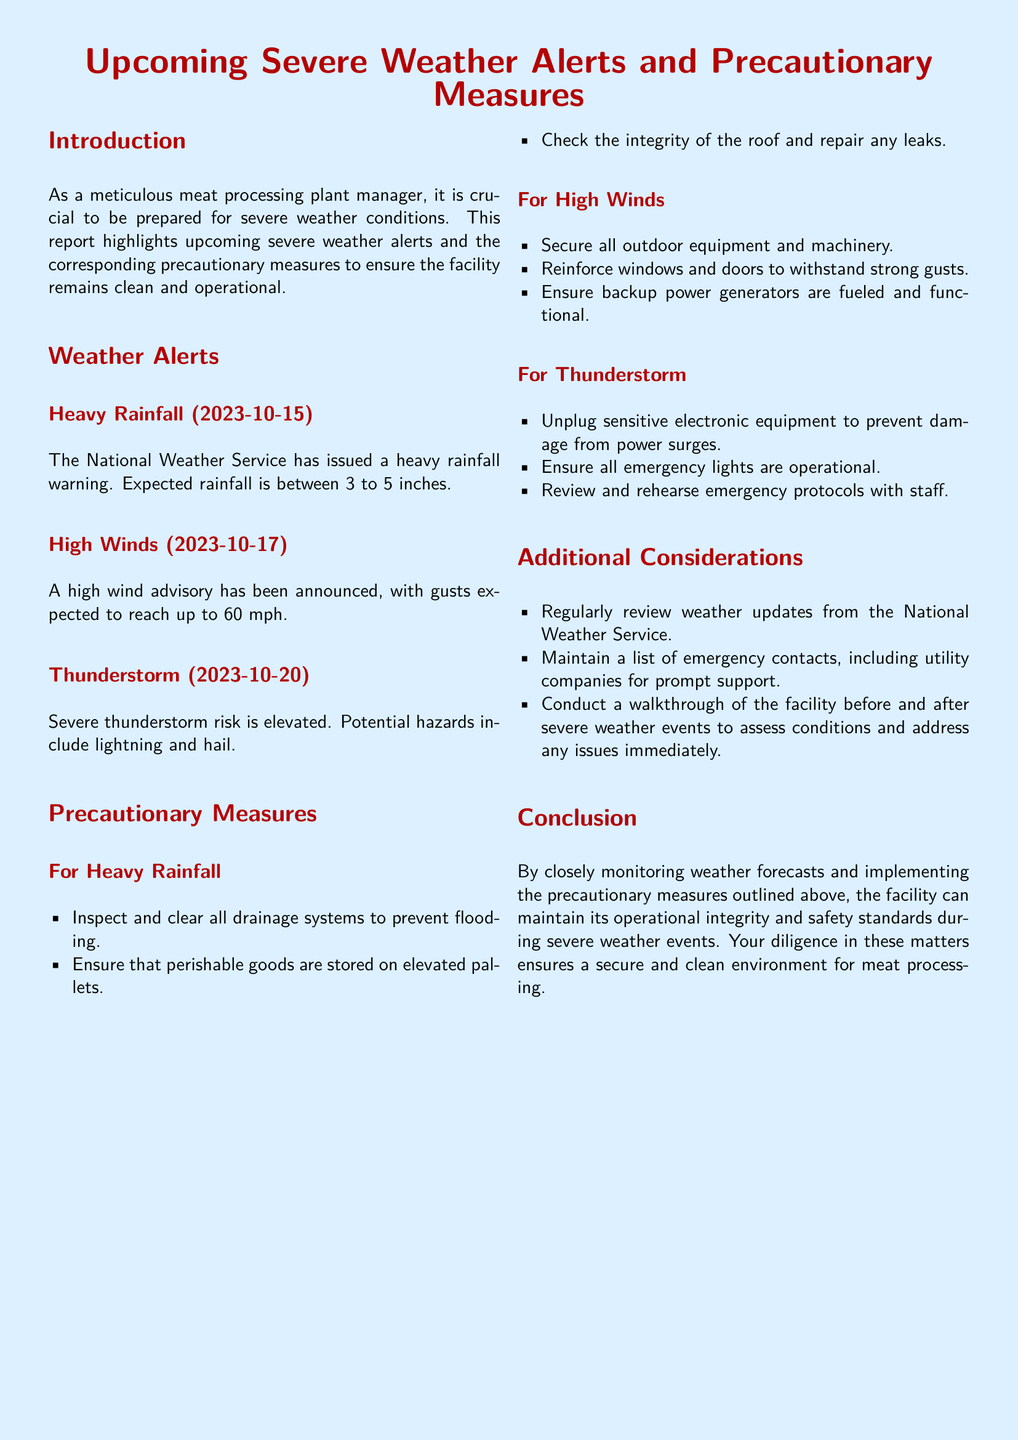What is the date of the heavy rainfall warning? The document states the heavy rainfall warning is issued for 2023-10-15.
Answer: 2023-10-15 What is the expected rainfall amount? The document indicates that expected rainfall is between 3 to 5 inches.
Answer: 3 to 5 inches What wind gust speed is anticipated? The document mentions gusts are expected to reach up to 60 mph during the high wind advisory.
Answer: 60 mph What should be done to perishable goods during heavy rainfall? The precautionary measure states perishable goods should be stored on elevated pallets.
Answer: Elevated pallets What is one precaution for thunderstorms? The document recommends unplugging sensitive electronic equipment to prevent damage from power surges as a precaution during thunderstorms.
Answer: Unplug sensitive electronic equipment Which organization issues weather updates? The document states that weather updates should be regularly reviewed from the National Weather Service.
Answer: National Weather Service What is one action to take for high winds? The document advises to secure all outdoor equipment and machinery during high winds.
Answer: Secure outdoor equipment How many inches of rainfall are predicted in the heavy rainfall alert? The document specifies the predicted rainfall amount is between 3 to 5 inches.
Answer: 3 to 5 inches What should be checked to ensure safety before a storm? The document suggests reviewing and rehearsing emergency protocols with staff before a storm.
Answer: Review and rehearse emergency protocols 